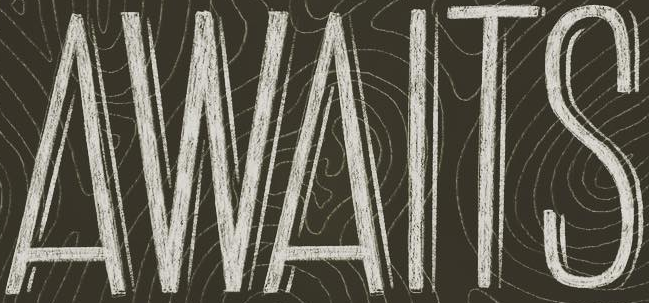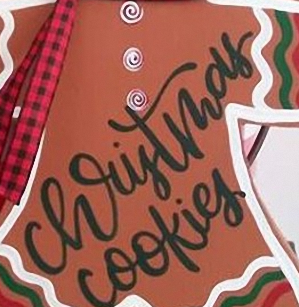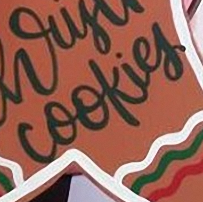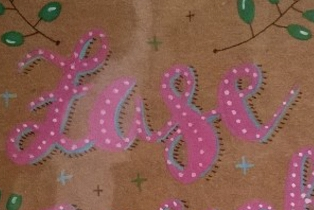Read the text content from these images in order, separated by a semicolon. AWAITS; christmas; cookies; Lase 